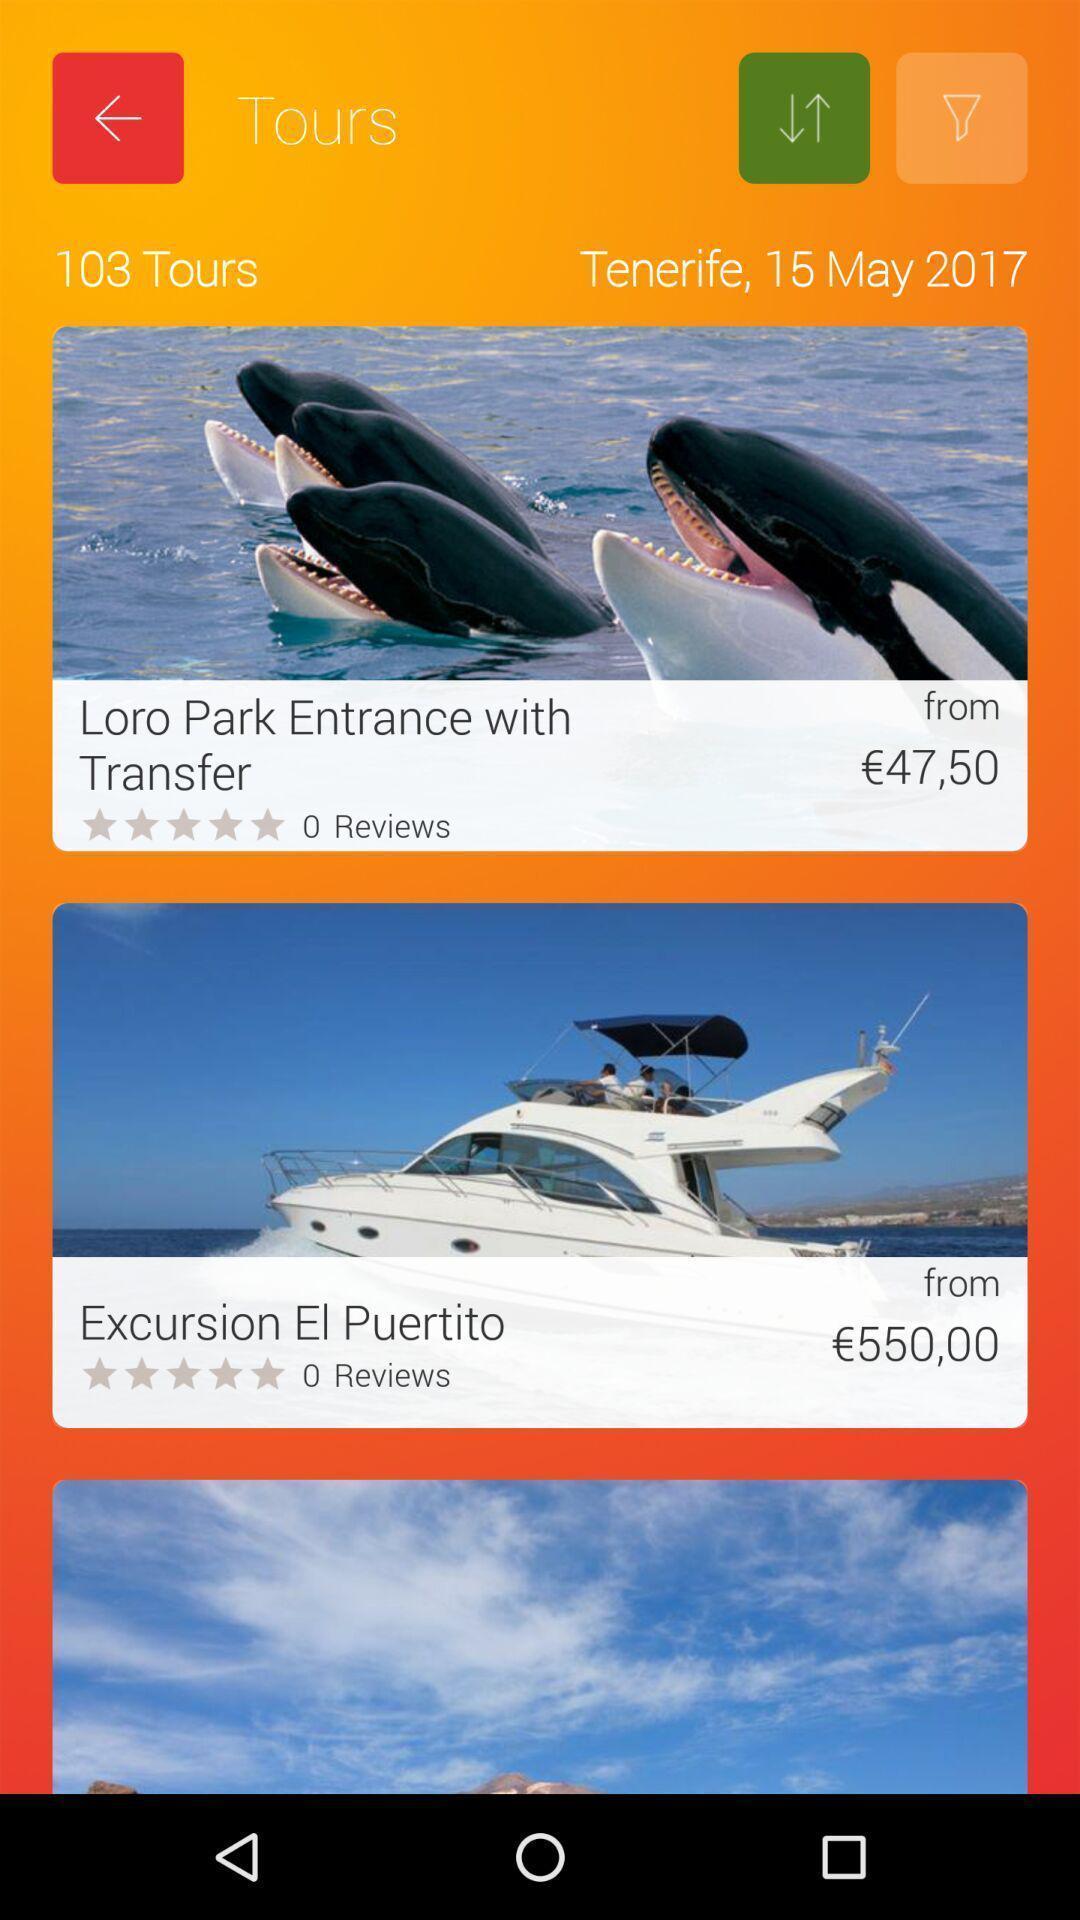Describe the content in this image. Tours page displayed of an travelling app. 